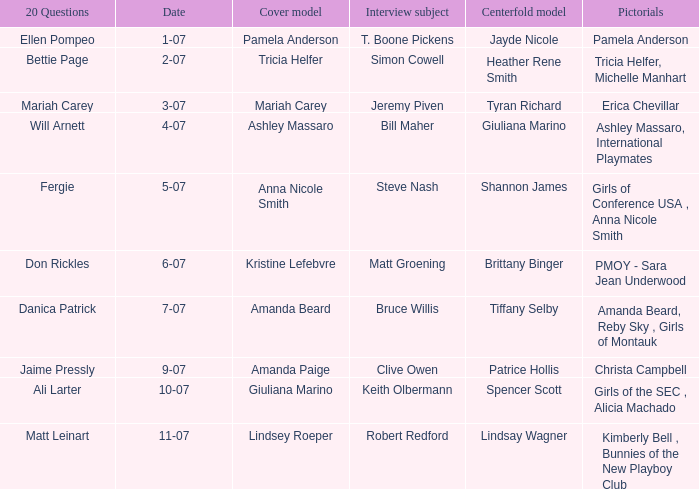List the pictorals from issues when lindsey roeper was the cover model. Kimberly Bell , Bunnies of the New Playboy Club. 